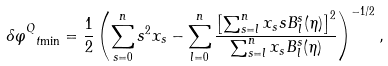Convert formula to latex. <formula><loc_0><loc_0><loc_500><loc_500>\delta \varphi _ { \ t { \min } } ^ { Q } = \frac { 1 } { 2 } \left ( \sum _ { s = 0 } ^ { n } s ^ { 2 } x _ { s } - \sum _ { l = 0 } ^ { n } \frac { \left [ \sum _ { s = l } ^ { n } x _ { s } s B ^ { s } _ { l } ( \eta ) \right ] ^ { 2 } } { \sum _ { s = l } ^ { n } x _ { s } B ^ { s } _ { l } ( \eta ) } \right ) ^ { - 1 / 2 } ,</formula> 